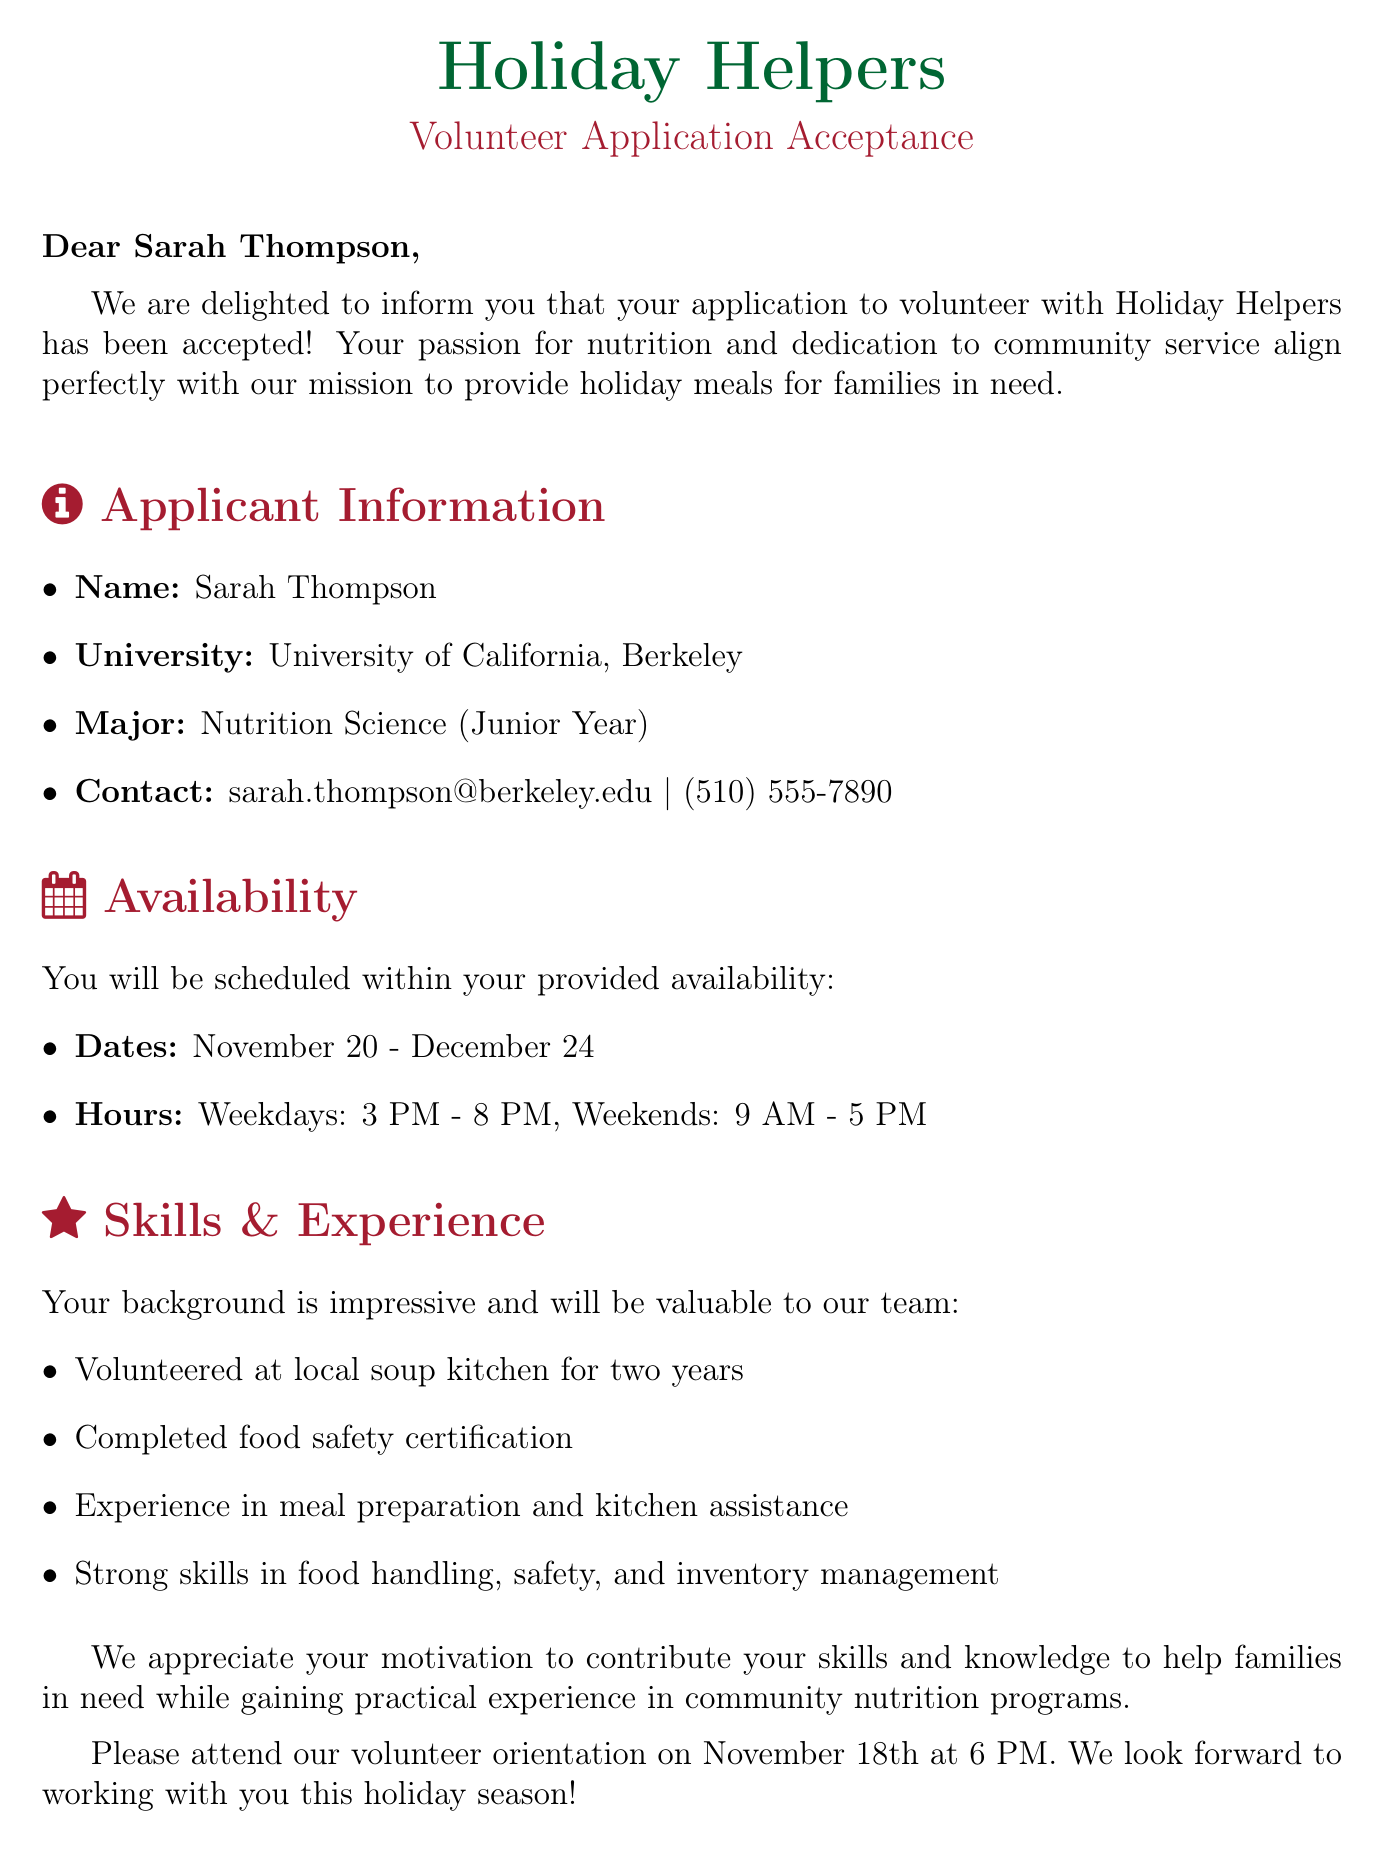What is the name of the applicant? The name of the applicant is stated in the document, which is Sarah Thompson.
Answer: Sarah Thompson What is the applicant's major? The applicant's major is listed in the document as Nutrition Science.
Answer: Nutrition Science What are the dates of availability for the volunteer? The document specifies the dates the applicant is available to volunteer from November 20 to December 24.
Answer: November 20 - December 24 What is the phone number provided by the applicant? The document includes the contact phone number that the applicant provided, which is (510) 555-7890.
Answer: (510) 555-7890 What experience does the applicant have? The document lists relevant experiences that indicate the applicant has volunteered at a soup kitchen, completed food safety certification, and worked as a kitchen assistant.
Answer: Volunteered at local soup kitchen for past two years How many years did the applicant volunteer at the soup kitchen? The document mentions the applicant volunteered at the local soup kitchen for the past two years.
Answer: Two years What motivational aspect does the applicant emphasize? The applicant's motivation statement mentions a passion for ensuring access to nutritious meals during the holiday season.
Answer: Access to nutritious meals What is the orientation date for volunteers? The document states the date for the volunteer orientation, which is November 18th.
Answer: November 18th 